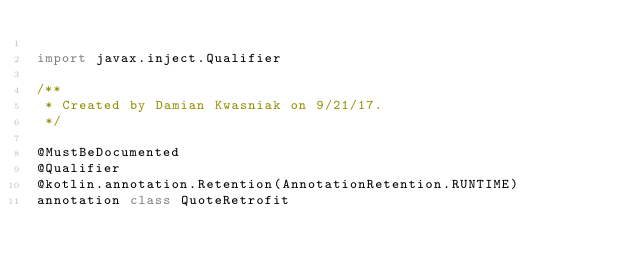Convert code to text. <code><loc_0><loc_0><loc_500><loc_500><_Kotlin_>
import javax.inject.Qualifier

/**
 * Created by Damian Kwasniak on 9/21/17.
 */

@MustBeDocumented
@Qualifier
@kotlin.annotation.Retention(AnnotationRetention.RUNTIME)
annotation class QuoteRetrofit</code> 